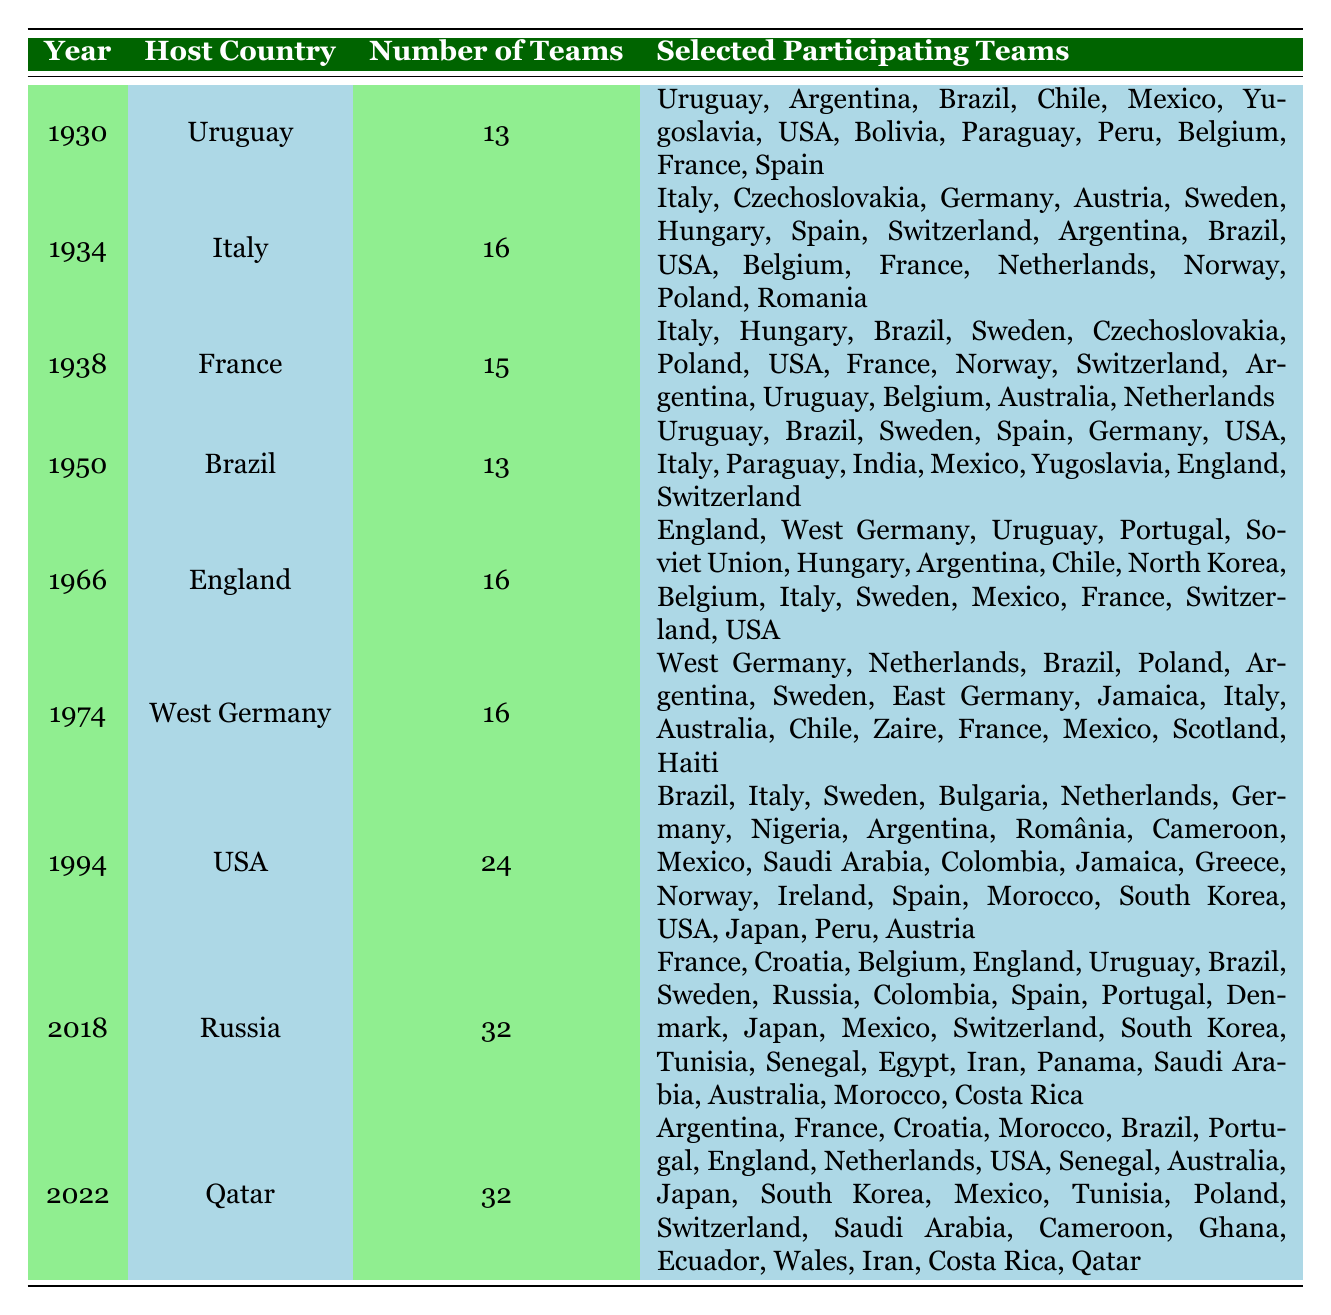What year did the FIFA World Cup have the highest number of participating teams? The table shows that in the years 1994, 2018, and 2022, the highest number of teams, which is 32, participated. Thus, the answer is that the highest number of participating teams was 32 in 1994, 2018, and 2022.
Answer: 1994, 2018, 2022 Which country hosted the FIFA World Cup in 1966? The table lists England as the host country for the 1966 FIFA World Cup.
Answer: England How many teams participated in the 1930 FIFA World Cup? The table indicates that there were 13 teams participating in the 1930 FIFA World Cup.
Answer: 13 Was Brazil among the teams that participated in the 1974 FIFA World Cup? By examining the table, Brazil is listed among the participating teams in the 1974 FIFA World Cup.
Answer: Yes What is the total number of teams that participated in the World Cups from 1930 to 2022? To find this, we sum the number of teams from each year: 13 (1930) + 16 (1934) + 15 (1938) + 13 (1950) + 16 (1966) + 16 (1974) + 24 (1994) + 32 (2018) + 32 (2022) gives us a total of  13 + 16 + 15 + 13 + 16 + 16 + 24 + 32 + 32 =  13 + 16 = 29, 29 + 15 = 44, 44 + 13 = 57, 57 + 16 = 73, 73 + 16 = 89, 89 + 24 = 113, 113 + 32 = 145, and finally 145 + 32 = 177.
Answer: 177 How many times did Italy participate in the FIFA World Cup by 2022? Referring to the table, Italy appears in the years 1934, 1938, 1966, 1974, and 1994, totaling 5 participations.
Answer: 5 Which FIFA World Cup had the least number of participating teams? The table shows that the fewest number of teams was 13 in both 1930 and 1950.
Answer: 1930, 1950 Did any World Cup hosted by Brazil have teams from Europe participating? By examining the table, in both the 1950 and 2014 World Cups hosted in Brazil, teams from Europe (Italy, France, etc.) did participate according to the table data.
Answer: Yes What is the difference in the number of participating teams between the 1994 and 2018 World Cups? According to the table, the 1994 World Cup had 24 teams and the 2018 World Cup had 32 teams. To find the difference, we subtract: 32 - 24 = 8.
Answer: 8 Which team marked its participation in the World Cup for the first time in 2022? The table presents that Qatar was the host of the 2022 FIFA World Cup and was also one of the teams participating, indicating that it marked its first participation in the World Cup.
Answer: Qatar 